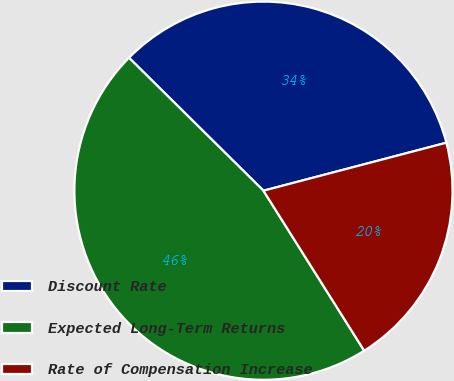Convert chart to OTSL. <chart><loc_0><loc_0><loc_500><loc_500><pie_chart><fcel>Discount Rate<fcel>Expected Long-Term Returns<fcel>Rate of Compensation Increase<nl><fcel>33.51%<fcel>46.35%<fcel>20.14%<nl></chart> 